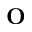Convert formula to latex. <formula><loc_0><loc_0><loc_500><loc_500>O</formula> 